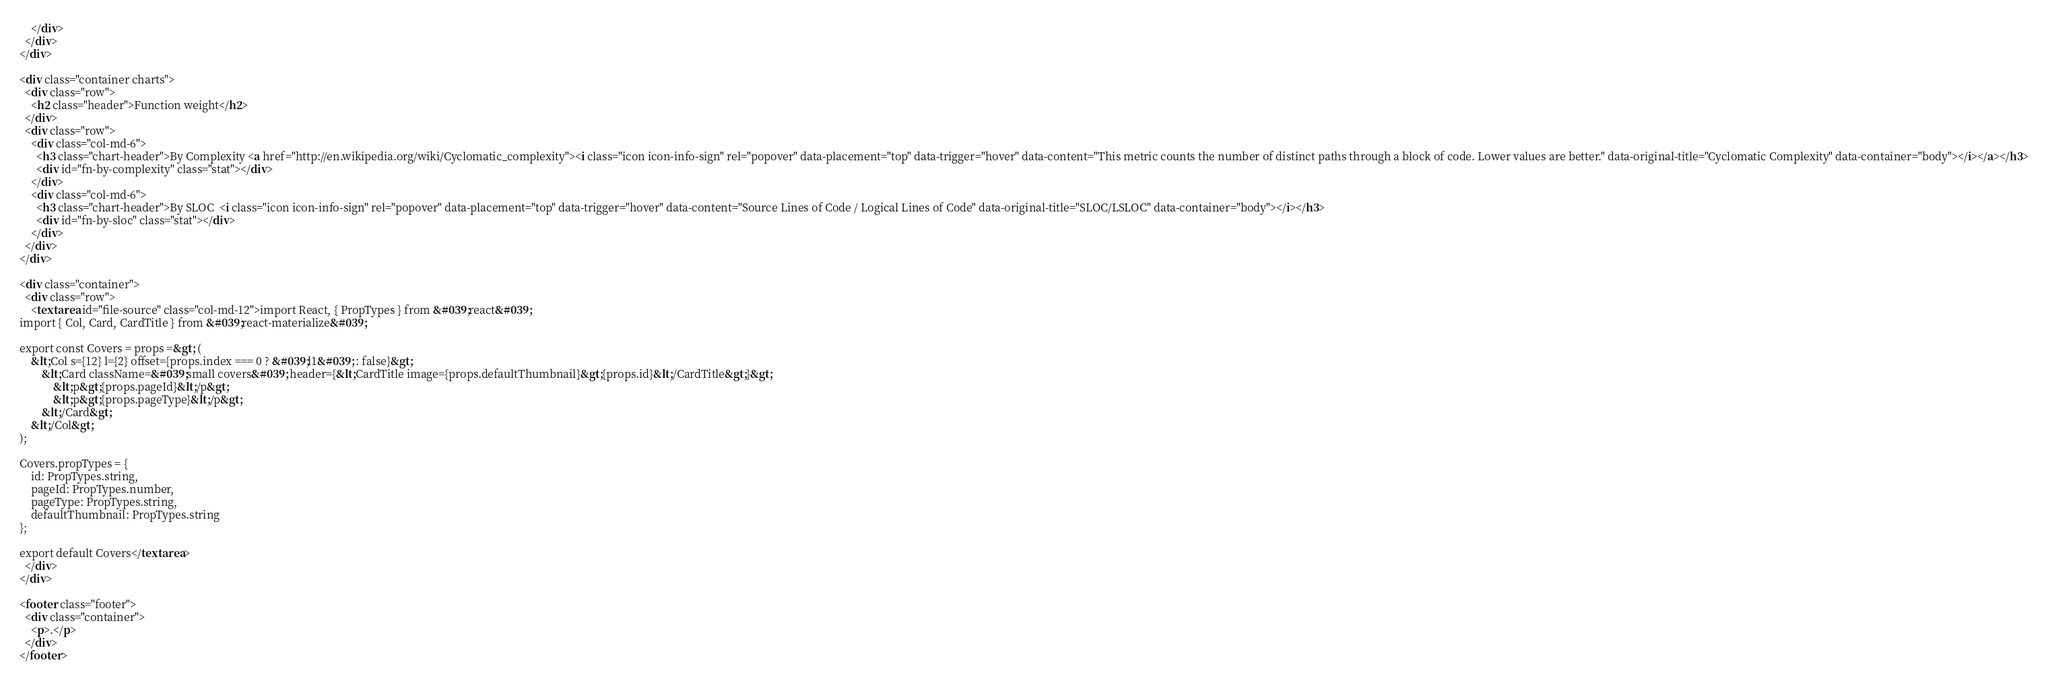<code> <loc_0><loc_0><loc_500><loc_500><_HTML_>    </div>
  </div>
</div>

<div class="container charts">
  <div class="row">
    <h2 class="header">Function weight</h2>
  </div>
  <div class="row">
    <div class="col-md-6">
      <h3 class="chart-header">By Complexity <a href="http://en.wikipedia.org/wiki/Cyclomatic_complexity"><i class="icon icon-info-sign" rel="popover" data-placement="top" data-trigger="hover" data-content="This metric counts the number of distinct paths through a block of code. Lower values are better." data-original-title="Cyclomatic Complexity" data-container="body"></i></a></h3>
      <div id="fn-by-complexity" class="stat"></div>
    </div>
    <div class="col-md-6">
      <h3 class="chart-header">By SLOC  <i class="icon icon-info-sign" rel="popover" data-placement="top" data-trigger="hover" data-content="Source Lines of Code / Logical Lines of Code" data-original-title="SLOC/LSLOC" data-container="body"></i></h3>
      <div id="fn-by-sloc" class="stat"></div>
    </div>
  </div>
</div>

<div class="container">
  <div class="row">
    <textarea id="file-source" class="col-md-12">import React, { PropTypes } from &#039;react&#039;
import { Col, Card, CardTitle } from &#039;react-materialize&#039;

export const Covers = props =&gt; (
    &lt;Col s={12} l={2} offset={props.index === 0 ? &#039;l1&#039; : false}&gt;
        &lt;Card className=&#039;small covers&#039; header={&lt;CardTitle image={props.defaultThumbnail}&gt;{props.id}&lt;/CardTitle&gt;}&gt;
            &lt;p&gt;{props.pageId}&lt;/p&gt;
            &lt;p&gt;{props.pageType}&lt;/p&gt;
        &lt;/Card&gt;
    &lt;/Col&gt;
);

Covers.propTypes = {
    id: PropTypes.string,
    pageId: PropTypes.number,
    pageType: PropTypes.string,
    defaultThumbnail: PropTypes.string
};

export default Covers</textarea>
  </div>
</div>

<footer class="footer">
  <div class="container">
    <p>.</p>
  </div>
</footer>
</code> 